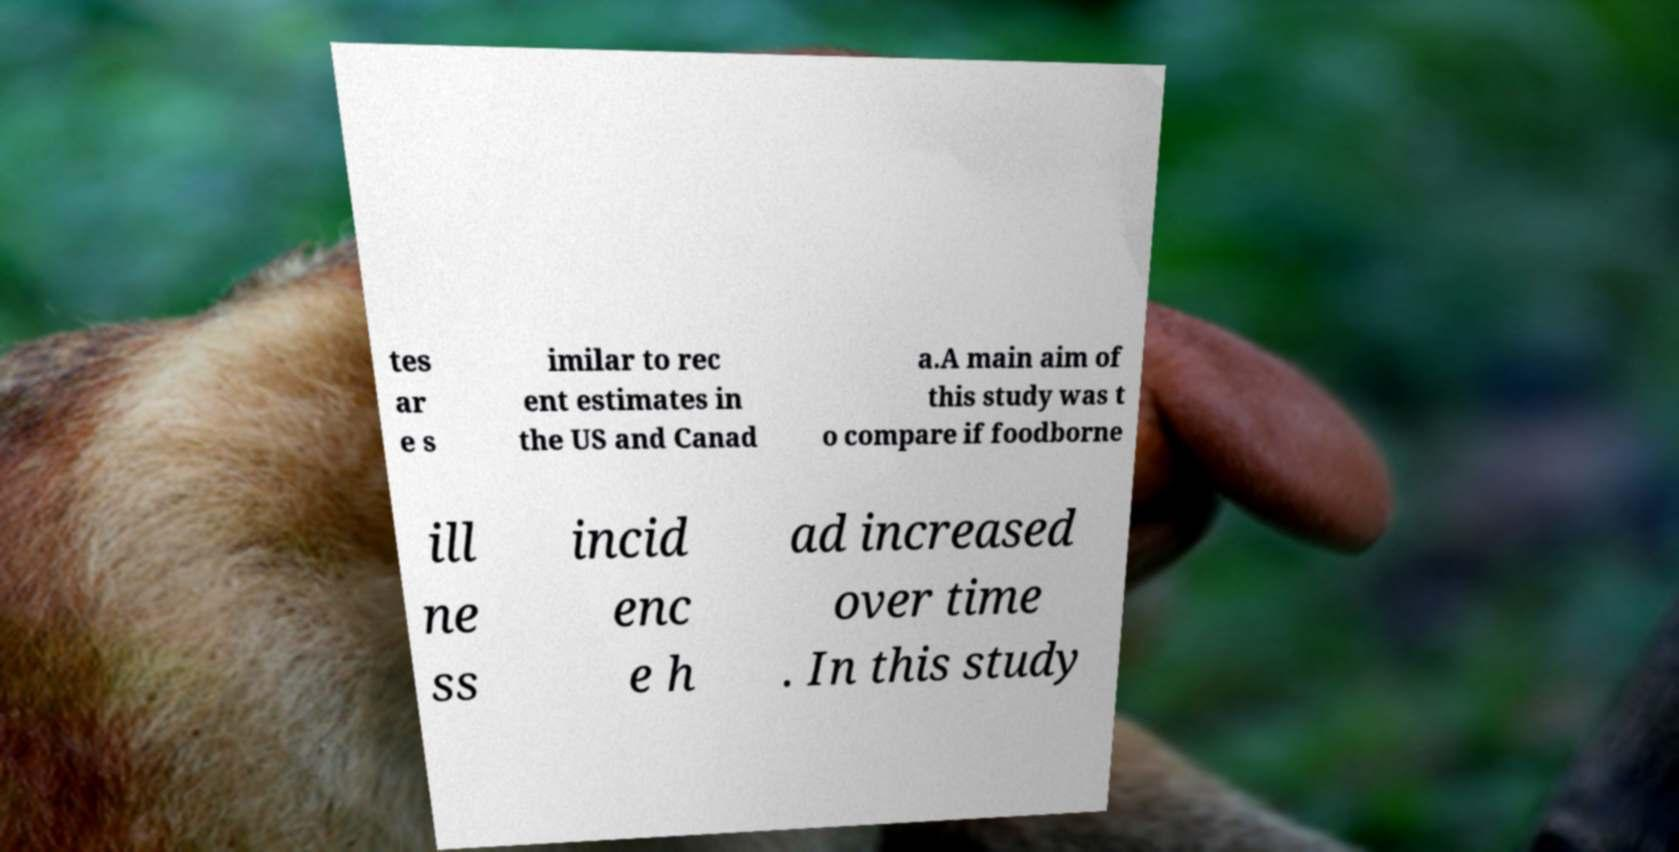Can you read and provide the text displayed in the image?This photo seems to have some interesting text. Can you extract and type it out for me? tes ar e s imilar to rec ent estimates in the US and Canad a.A main aim of this study was t o compare if foodborne ill ne ss incid enc e h ad increased over time . In this study 